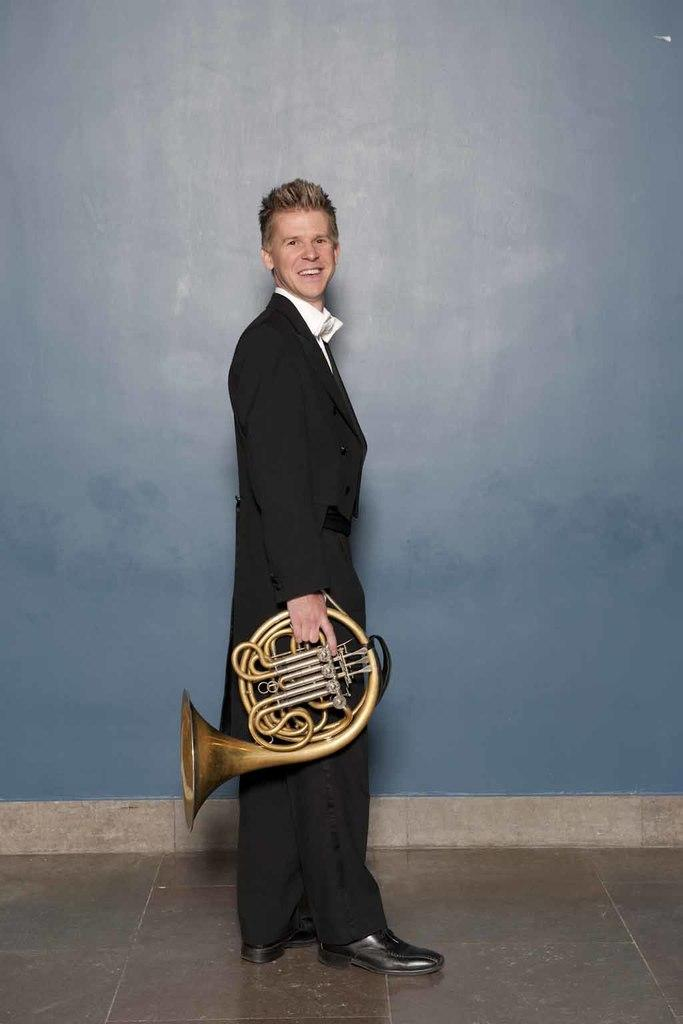What is the man in the image holding? The man is holding a french horn. What is the man's position in the image? The man is standing on the floor. What is the man's facial expression in the image? The man is smiling. What can be seen in the background of the image? There is a wall in the background of the image. What type of loaf is the man holding in the image? The man is not holding a loaf in the image; he is holding a french horn. What cast member from the movie "Shame" can be seen in the image? There is no cast member from the movie "Shame" present in the image. 